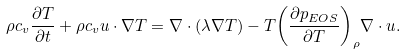Convert formula to latex. <formula><loc_0><loc_0><loc_500><loc_500>\rho { c _ { v } } \frac { \partial T } { \partial t } + \rho { c _ { v } } { u } \cdot \nabla T = \nabla \cdot \left ( { \lambda \nabla T } \right ) - T { \left ( { \frac { { \partial { p _ { E O S } } } } { \partial T } } \right ) _ { \rho } } \nabla \cdot { u } .</formula> 